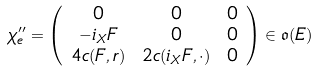<formula> <loc_0><loc_0><loc_500><loc_500>\chi ^ { \prime \prime } _ { e } & = \left ( \begin{array} { c c c } 0 & 0 & 0 \\ - i _ { X } F & 0 & 0 \\ 4 c ( F , r ) & 2 c ( i _ { X } F , \cdot ) & 0 \end{array} \right ) \in \mathfrak { o } ( E )</formula> 